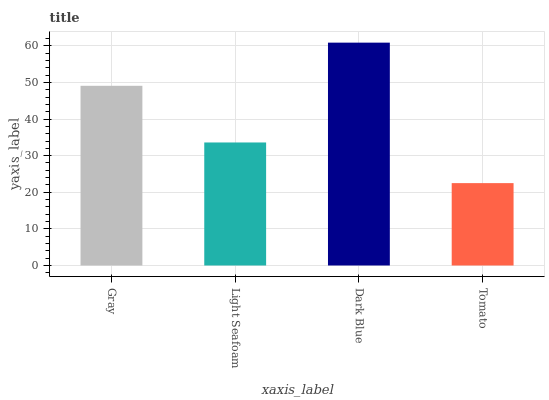Is Light Seafoam the minimum?
Answer yes or no. No. Is Light Seafoam the maximum?
Answer yes or no. No. Is Gray greater than Light Seafoam?
Answer yes or no. Yes. Is Light Seafoam less than Gray?
Answer yes or no. Yes. Is Light Seafoam greater than Gray?
Answer yes or no. No. Is Gray less than Light Seafoam?
Answer yes or no. No. Is Gray the high median?
Answer yes or no. Yes. Is Light Seafoam the low median?
Answer yes or no. Yes. Is Tomato the high median?
Answer yes or no. No. Is Tomato the low median?
Answer yes or no. No. 